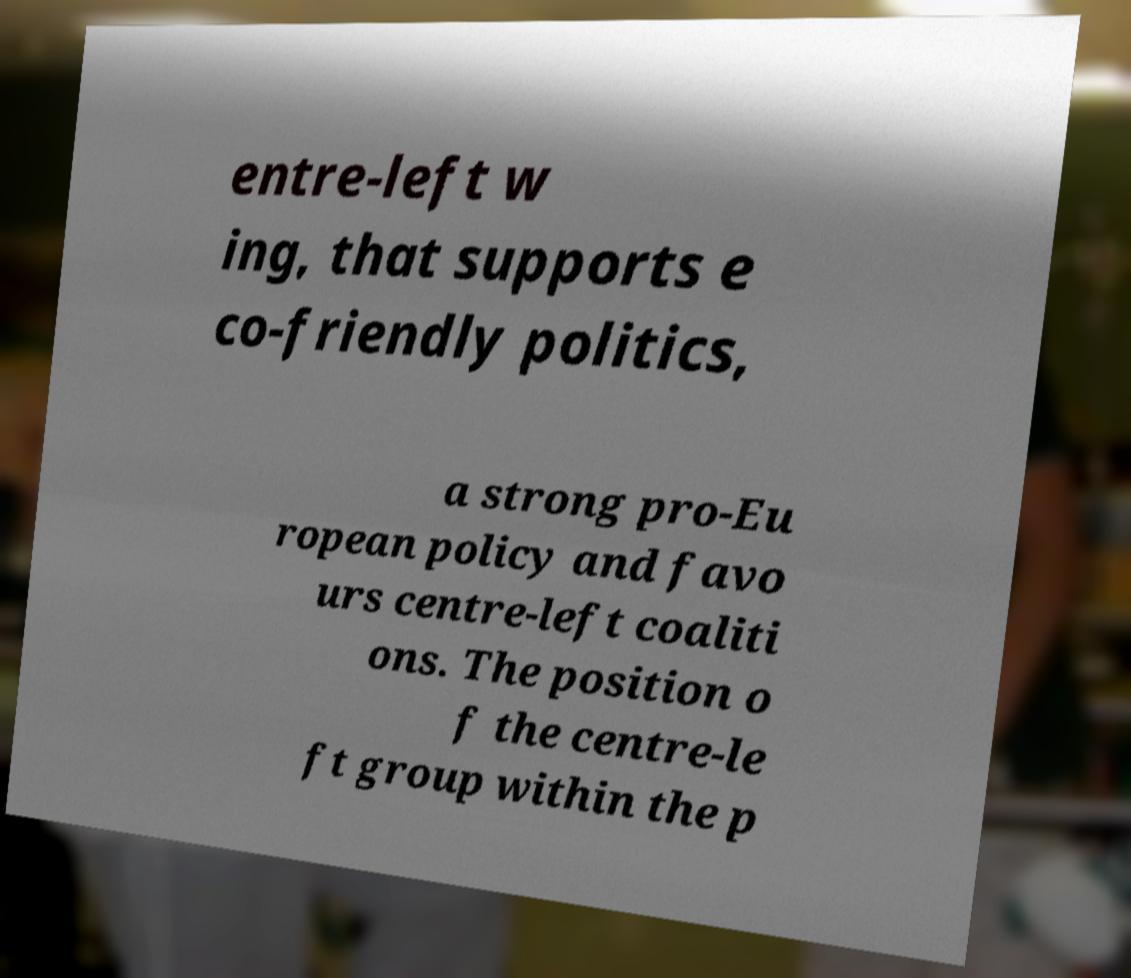What messages or text are displayed in this image? I need them in a readable, typed format. entre-left w ing, that supports e co-friendly politics, a strong pro-Eu ropean policy and favo urs centre-left coaliti ons. The position o f the centre-le ft group within the p 